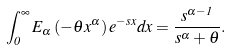Convert formula to latex. <formula><loc_0><loc_0><loc_500><loc_500>\int _ { 0 } ^ { \infty } E _ { \alpha } \left ( - \theta x ^ { \alpha } \right ) e ^ { - s x } d x = \frac { s ^ { \alpha - 1 } } { s ^ { \alpha } + \theta } .</formula> 